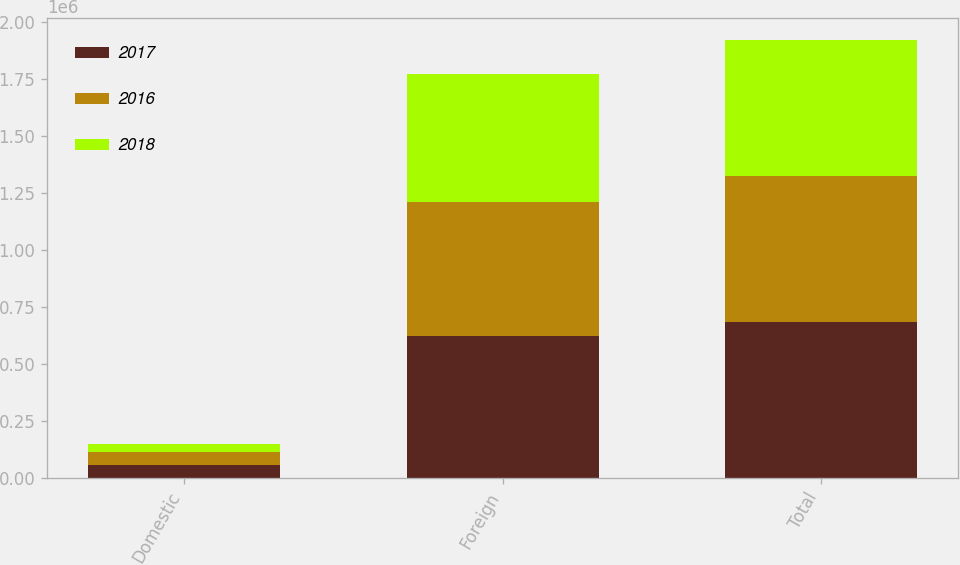<chart> <loc_0><loc_0><loc_500><loc_500><stacked_bar_chart><ecel><fcel>Domestic<fcel>Foreign<fcel>Total<nl><fcel>2017<fcel>57822<fcel>624324<fcel>682146<nl><fcel>2016<fcel>55751<fcel>585346<fcel>641097<nl><fcel>2018<fcel>35154<fcel>564960<fcel>600114<nl></chart> 